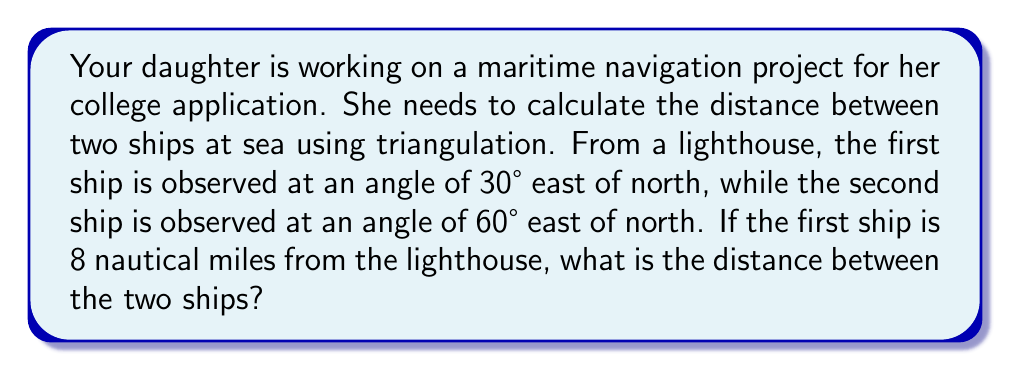Show me your answer to this math problem. Let's approach this problem step-by-step using trigonometry:

1) First, let's visualize the problem:

[asy]
import geometry;

size(200);
pair A = (0,0);  // Lighthouse
pair B = (4*sqrt(3),4);  // Ship 1
pair C = (4*sqrt(3),7);  // Ship 2

draw(A--B--C--A);
draw(A--(0,8), dashed);

label("Lighthouse", A, SW);
label("Ship 1", B, E);
label("Ship 2", C, E);
label("8 nm", (A+B)/2, NW);
label("30°", A, NE);
label("30°", A, N);

dot(A);
dot(B);
dot(C);
[/asy]

2) We can see that we have a triangle formed by the lighthouse and the two ships.

3) We know one side of this triangle (the distance to Ship 1), and we can find the angle between the two lines of sight:
   $60° - 30° = 30°$

4) To find the distance between the ships, we can use the law of cosines:
   $c^2 = a^2 + b^2 - 2ab \cos(C)$

   Where:
   $c$ is the distance between the ships (what we're looking for)
   $a$ is the distance to Ship 1 (8 nautical miles)
   $b$ is the distance to Ship 2 (unknown, but we don't need it)
   $C$ is the angle between the lines of sight (30°)

5) We don't know $b$, but we can use the law of sines to find it:
   $\frac{a}{\sin A} = \frac{b}{\sin B}$

   We know $a$ (8 nm) and $A$ (30°). $B$ is also 30° because the sum of angles in a triangle is 180°, and we know two angles (30° and 120°).

   $\frac{8}{\sin 30°} = \frac{b}{\sin 30°}$

   Therefore, $b = 8$ nautical miles as well.

6) Now we can use the law of cosines:

   $c^2 = 8^2 + 8^2 - 2(8)(8) \cos(30°)$

7) Simplify:
   $c^2 = 64 + 64 - 128 \cos(30°)$
   $c^2 = 128 - 128 (\frac{\sqrt{3}}{2})$
   $c^2 = 128 - 64\sqrt{3}$

8) Take the square root of both sides:
   $c = \sqrt{128 - 64\sqrt{3}}$

9) Simplify:
   $c = 4\sqrt{8 - 4\sqrt{3}}$
Answer: The distance between the two ships is $4\sqrt{8 - 4\sqrt{3}}$ nautical miles. 